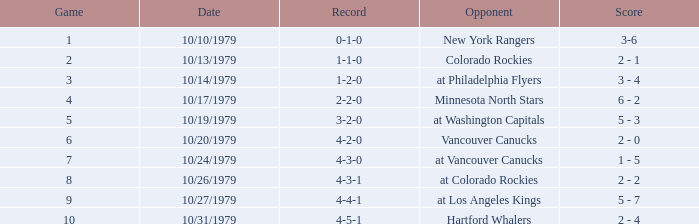Who is the opponent before game 5 with a 0-1-0 record? New York Rangers. 